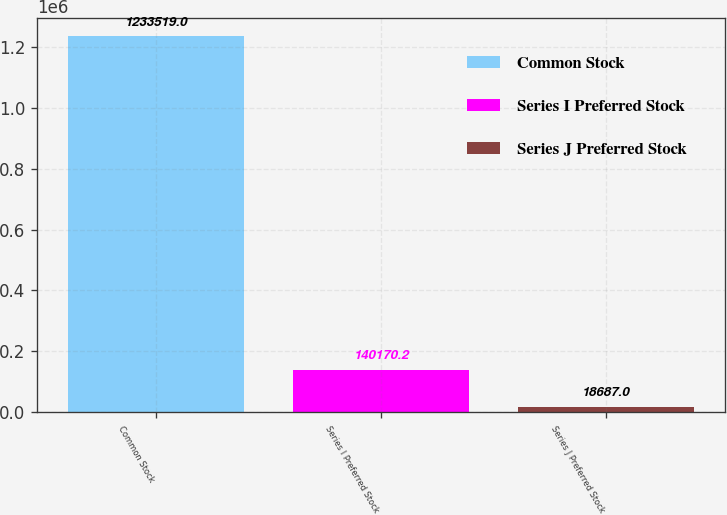Convert chart to OTSL. <chart><loc_0><loc_0><loc_500><loc_500><bar_chart><fcel>Common Stock<fcel>Series I Preferred Stock<fcel>Series J Preferred Stock<nl><fcel>1.23352e+06<fcel>140170<fcel>18687<nl></chart> 